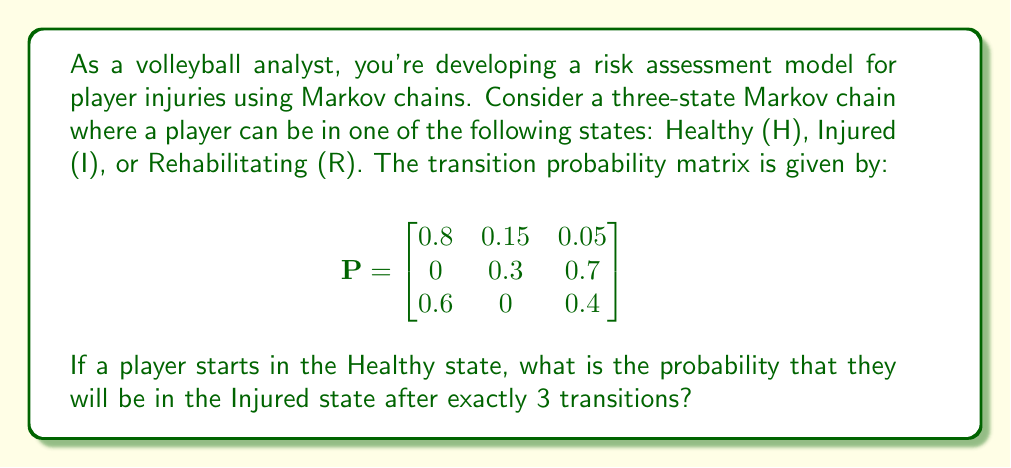What is the answer to this math problem? To solve this problem, we need to use the properties of Markov chains and matrix multiplication. Let's break it down step by step:

1) The initial state vector is $\mathbf{v}_0 = [1, 0, 0]$, as the player starts in the Healthy state.

2) To find the state after 3 transitions, we need to multiply the initial state vector by the transition matrix $P$ three times:

   $\mathbf{v}_3 = \mathbf{v}_0 P^3$

3) Let's calculate $P^2$ first:

   $$P^2 = \begin{bmatrix}
   0.8 & 0.15 & 0.05 \\
   0 & 0.3 & 0.7 \\
   0.6 & 0 & 0.4
   \end{bmatrix} \times \begin{bmatrix}
   0.8 & 0.15 & 0.05 \\
   0 & 0.3 & 0.7 \\
   0.6 & 0 & 0.4
   \end{bmatrix}$$

   $$= \begin{bmatrix}
   0.67 & 0.165 & 0.165 \\
   0.42 & 0.09 & 0.49 \\
   0.72 & 0.09 & 0.19
   \end{bmatrix}$$

4) Now let's calculate $P^3$:

   $$P^3 = P^2 \times P = \begin{bmatrix}
   0.67 & 0.165 & 0.165 \\
   0.42 & 0.09 & 0.49 \\
   0.72 & 0.09 & 0.19
   \end{bmatrix} \times \begin{bmatrix}
   0.8 & 0.15 & 0.05 \\
   0 & 0.3 & 0.7 \\
   0.6 & 0 & 0.4
   \end{bmatrix}$$

   $$= \begin{bmatrix}
   0.635 & 0.1545 & 0.2105 \\
   0.558 & 0.0885 & 0.3535 \\
   0.684 & 0.1305 & 0.1855
   \end{bmatrix}$$

5) Now we multiply the initial state vector by $P^3$:

   $\mathbf{v}_3 = [1, 0, 0] \times \begin{bmatrix}
   0.635 & 0.1545 & 0.2105 \\
   0.558 & 0.0885 & 0.3535 \\
   0.684 & 0.1305 & 0.1855
   \end{bmatrix} = [0.635, 0.1545, 0.2105]$

6) The probability of being in the Injured state (the second state) after 3 transitions is the second element of this vector: 0.1545.
Answer: 0.1545 